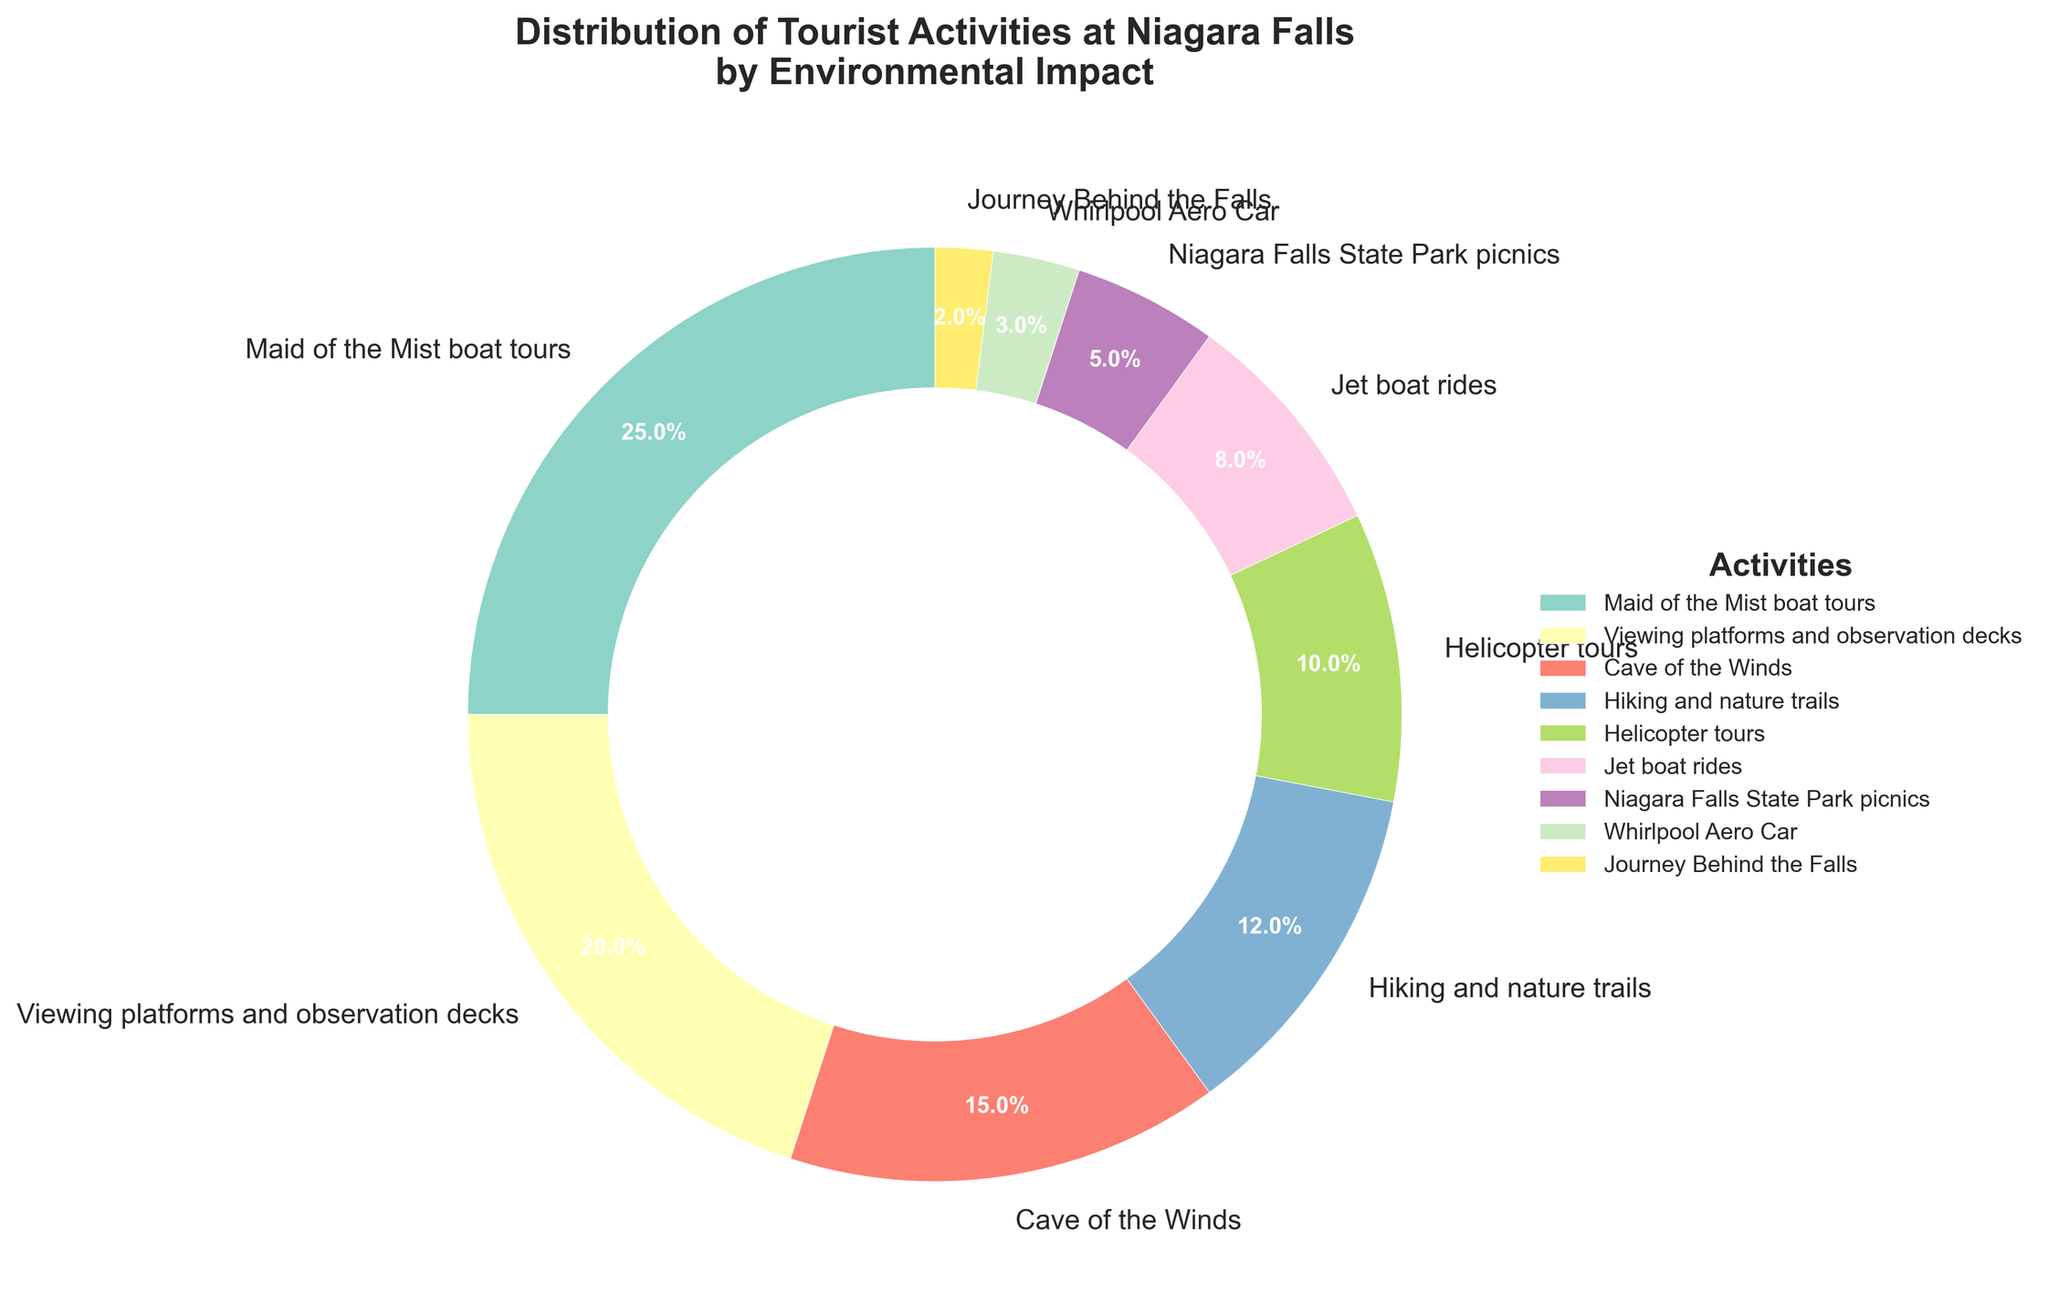What is the total percentage of activities that have a less than 10% impact? To find the total percentage of activities with less than 10% impact, sum the percentages of activities that meet this condition. Look for activities that have a percentage below 10%. Here they are: Helicopter tours (10%), Jet boat rides (8%), Niagara Falls State Park picnics (5%), Whirlpool Aero Car (3%), Journey Behind the Falls (2%). Add these together: 10% + 8% + 5% + 3% + 2% = 28%.
Answer: 28% Which activity has the highest environmental impact? To identify the activity with the highest environmental impact, look for the activity with the largest percentage. Maid of the Mist boat tours, with 25%, has the highest impact.
Answer: Maid of the Mist boat tours Which activity has the smallest environmental impact? To identify the activity with the smallest environmental impact, look for the activity with the lowest percentage. Journey Behind the Falls, with 2%, has the smallest impact.
Answer: Journey Behind the Falls How much greater is the impact of viewing platforms and observation decks compared to Whirlpool Aero Car? To determine how much greater the impact of viewing platforms and observation decks (20%) is compared to Whirlpool Aero Car (3%), subtract the percentage of Whirlpool Aero Car from that of the viewing platforms and observation decks: 20% - 3% = 17%.
Answer: 17% How do the impacts of Hiking and nature trails and Helicopter tours compare? Hiking and nature trails have an impact of 12%, while Helicopter tours have an impact of 10%. Compare the two values by subtraction: 12% - 10% = 2%. Hiking and nature trails have a 2% higher impact than Helicopter tours.
Answer: Hiking and nature trails have a 2% higher impact What percentage of activities have an impact between 5% and 15%? To find the percentage of activities with an impact between 5% and 15%, sum the percentages of these activities: Cave of the Winds (15%), Hiking and nature trails (12%), Helicopter tours (10%), Jet boat rides (8%). Add these together: 15% + 12% + 10% + 8% = 45%.
Answer: 45% Which three activities have the most significant environmental impact and what is their combined percentage? To identify the three activities with the most significant impact, list the activities with the highest percentages and sum their values. The top three are: Maid of the Mist boat tours (25%), Viewing platforms and observation decks (20%), Cave of the Winds (15%). Add these together: 25% + 20% + 15% = 60%.
Answer: Maid of the Mist boat tours, Viewing platforms and observation decks, Cave of the Winds; 60% Is there any activity that has an equal environmental impact to Jet boat rides? Jet boat rides have an impact of 8%. By looking at the chart, no other activity has exactly 8% impact.
Answer: No Which of the activities use aerial transportation, and what is their combined environmental impact? To determine which activities use aerial transportation and their combined environmental impact, identify activities related to air travel. Helicopter tours (10%) and Whirlpool Aero Car (3%) are the relevant activities. Add their impacts: 10% + 3% = 13%.
Answer: Helicopter tours, Whirlpool Aero Car; 13% 